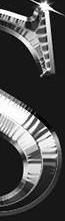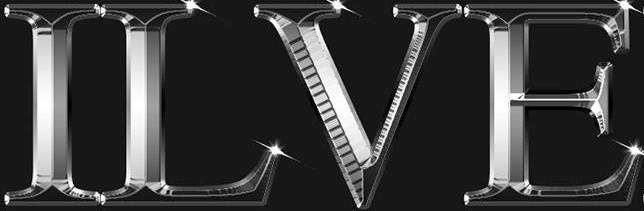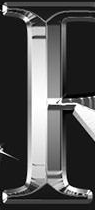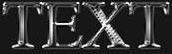Identify the words shown in these images in order, separated by a semicolon. #; ILVE; #; TEXT 